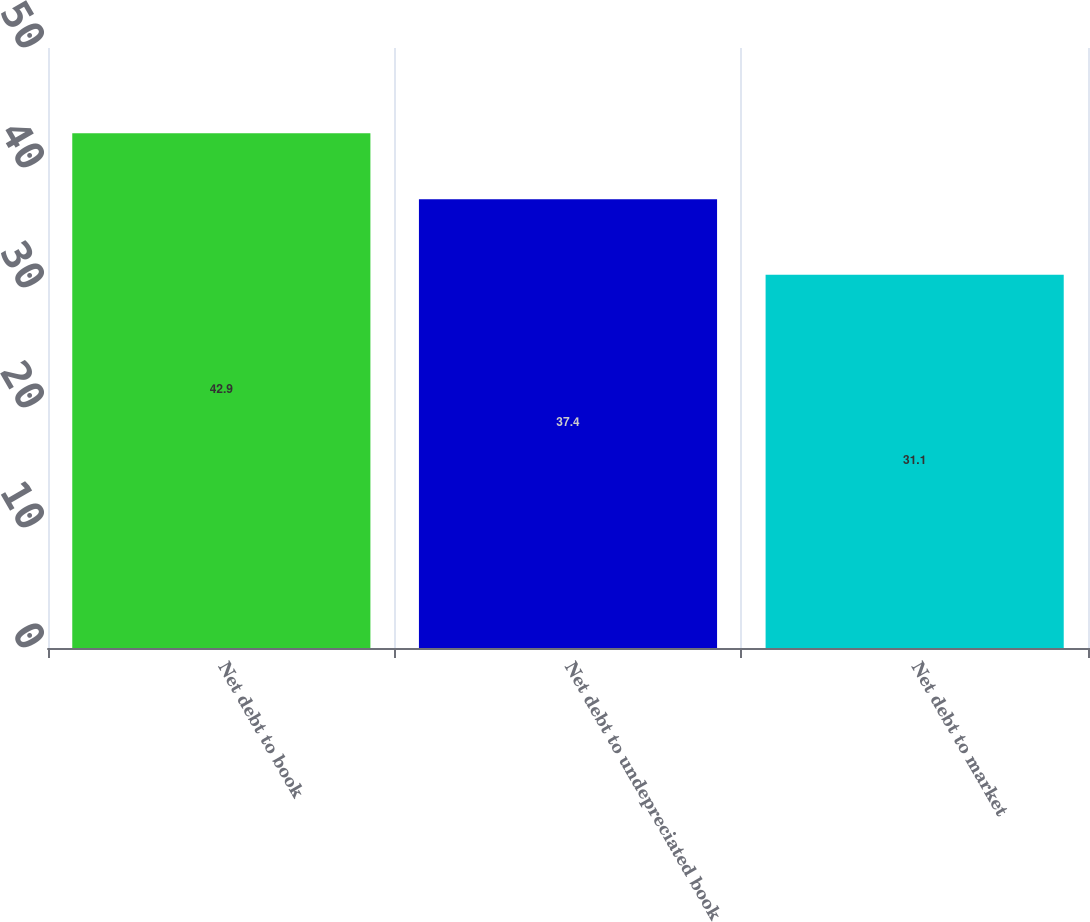Convert chart. <chart><loc_0><loc_0><loc_500><loc_500><bar_chart><fcel>Net debt to book<fcel>Net debt to undepreciated book<fcel>Net debt to market<nl><fcel>42.9<fcel>37.4<fcel>31.1<nl></chart> 